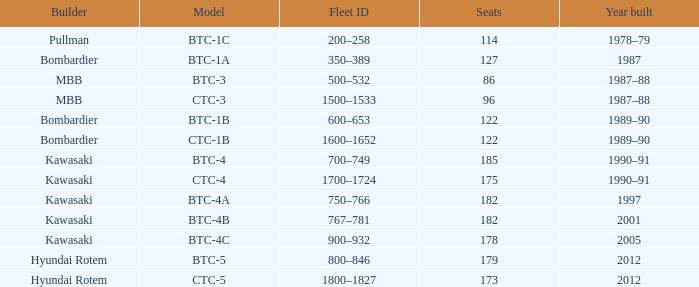In what year was the ctc-3 model built? 1987–88. 